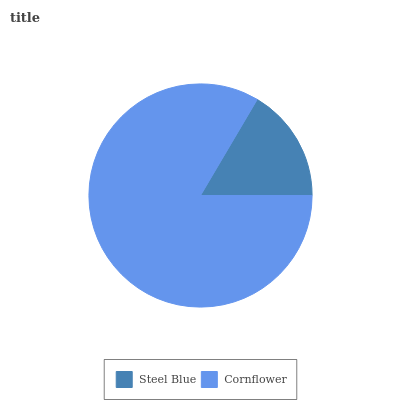Is Steel Blue the minimum?
Answer yes or no. Yes. Is Cornflower the maximum?
Answer yes or no. Yes. Is Cornflower the minimum?
Answer yes or no. No. Is Cornflower greater than Steel Blue?
Answer yes or no. Yes. Is Steel Blue less than Cornflower?
Answer yes or no. Yes. Is Steel Blue greater than Cornflower?
Answer yes or no. No. Is Cornflower less than Steel Blue?
Answer yes or no. No. Is Cornflower the high median?
Answer yes or no. Yes. Is Steel Blue the low median?
Answer yes or no. Yes. Is Steel Blue the high median?
Answer yes or no. No. Is Cornflower the low median?
Answer yes or no. No. 